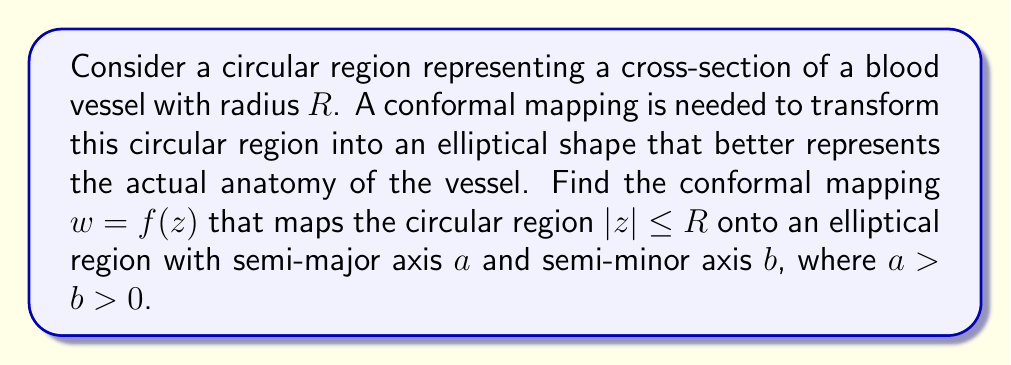Could you help me with this problem? To solve this problem, we'll follow these steps:

1) First, recall that the Joukowski transformation is a conformal mapping that can transform a circle into an ellipse. The general form of the Joukowski transformation is:

   $$w = \frac{1}{2}(z + \frac{c^2}{z})$$

   where $c$ is a real constant.

2) We need to adjust this transformation to map our circle of radius $R$ to an ellipse with semi-major axis $a$ and semi-minor axis $b$. We can do this by scaling and translating the Joukowski transformation.

3) Let's start with a circle of radius $R$ centered at the origin. We'll first apply a scaled Joukowski transformation:

   $$w_1 = k(z + \frac{c^2}{z})$$

   where $k$ is a scaling factor and $c$ is a parameter we'll determine later.

4) To ensure that points on the circle $|z| = R$ map to points on the ellipse, we substitute $z = Re^{i\theta}$:

   $$w_1 = k(Re^{i\theta} + \frac{c^2}{Re^{i\theta}}) = k(Re^{i\theta} + \frac{c^2}{R}e^{-i\theta})$$

5) Using Euler's formula, we can express this as:

   $$w_1 = k[(R + \frac{c^2}{R})\cos\theta + i(R - \frac{c^2}{R})\sin\theta]$$

6) For this to be an ellipse with semi-major axis $a$ and semi-minor axis $b$, we need:

   $$k(R + \frac{c^2}{R}) = a$$
   $$k(R - \frac{c^2}{R}) = b$$

7) Solving these equations:

   $$c^2 = R^2\frac{a-b}{a+b}$$
   $$k = \frac{a+b}{2R}$$

8) Therefore, our conformal mapping is:

   $$w = \frac{a+b}{4R}(z + \frac{R^2(a-b)}{(a+b)z})$$

This mapping transforms the circular region $|z| \leq R$ onto an elliptical region with semi-major axis $a$ and semi-minor axis $b$.
Answer: The conformal mapping that transforms the circular region $|z| \leq R$ onto an elliptical region with semi-major axis $a$ and semi-minor axis $b$ is:

$$w = \frac{a+b}{4R}(z + \frac{R^2(a-b)}{(a+b)z})$$ 